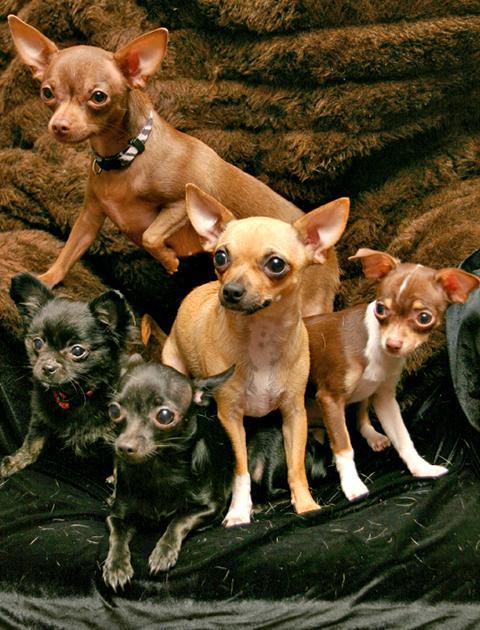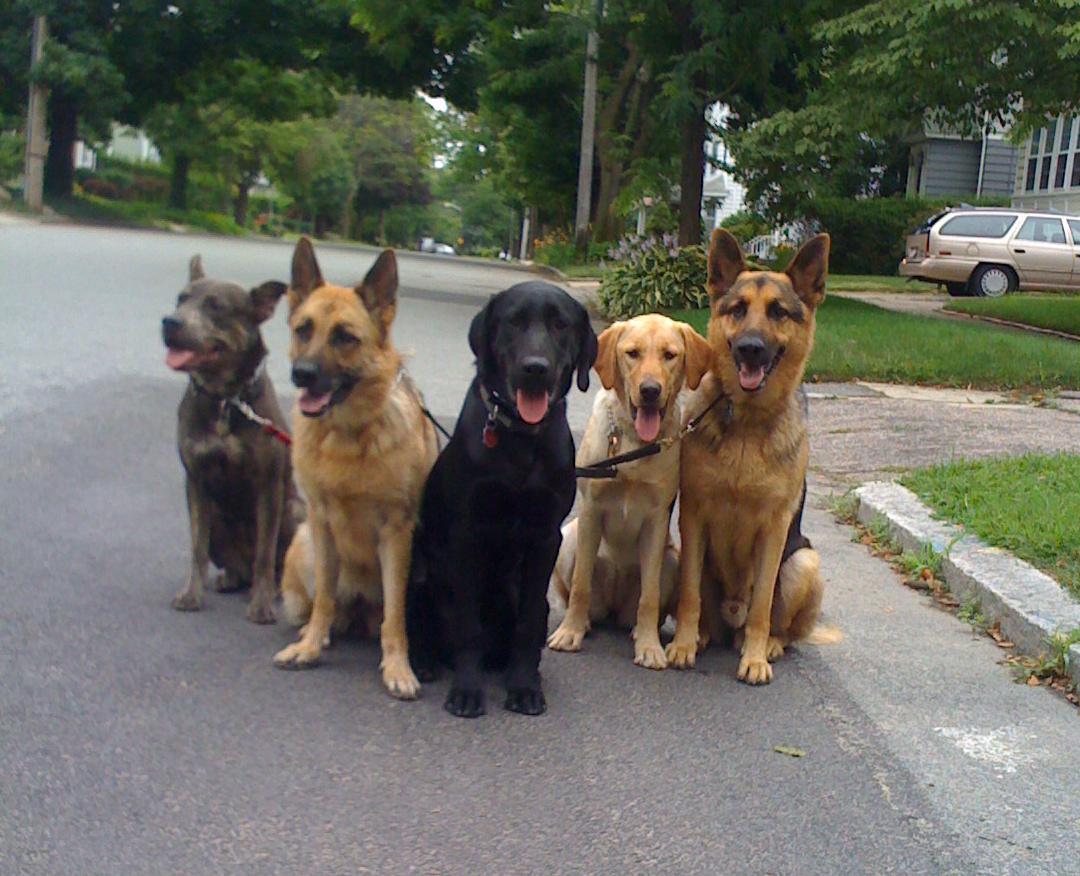The first image is the image on the left, the second image is the image on the right. For the images shown, is this caption "One image contains exactly three dogs." true? Answer yes or no. No. The first image is the image on the left, the second image is the image on the right. Analyze the images presented: Is the assertion "there is a row of animals dressed in clothes" valid? Answer yes or no. No. 